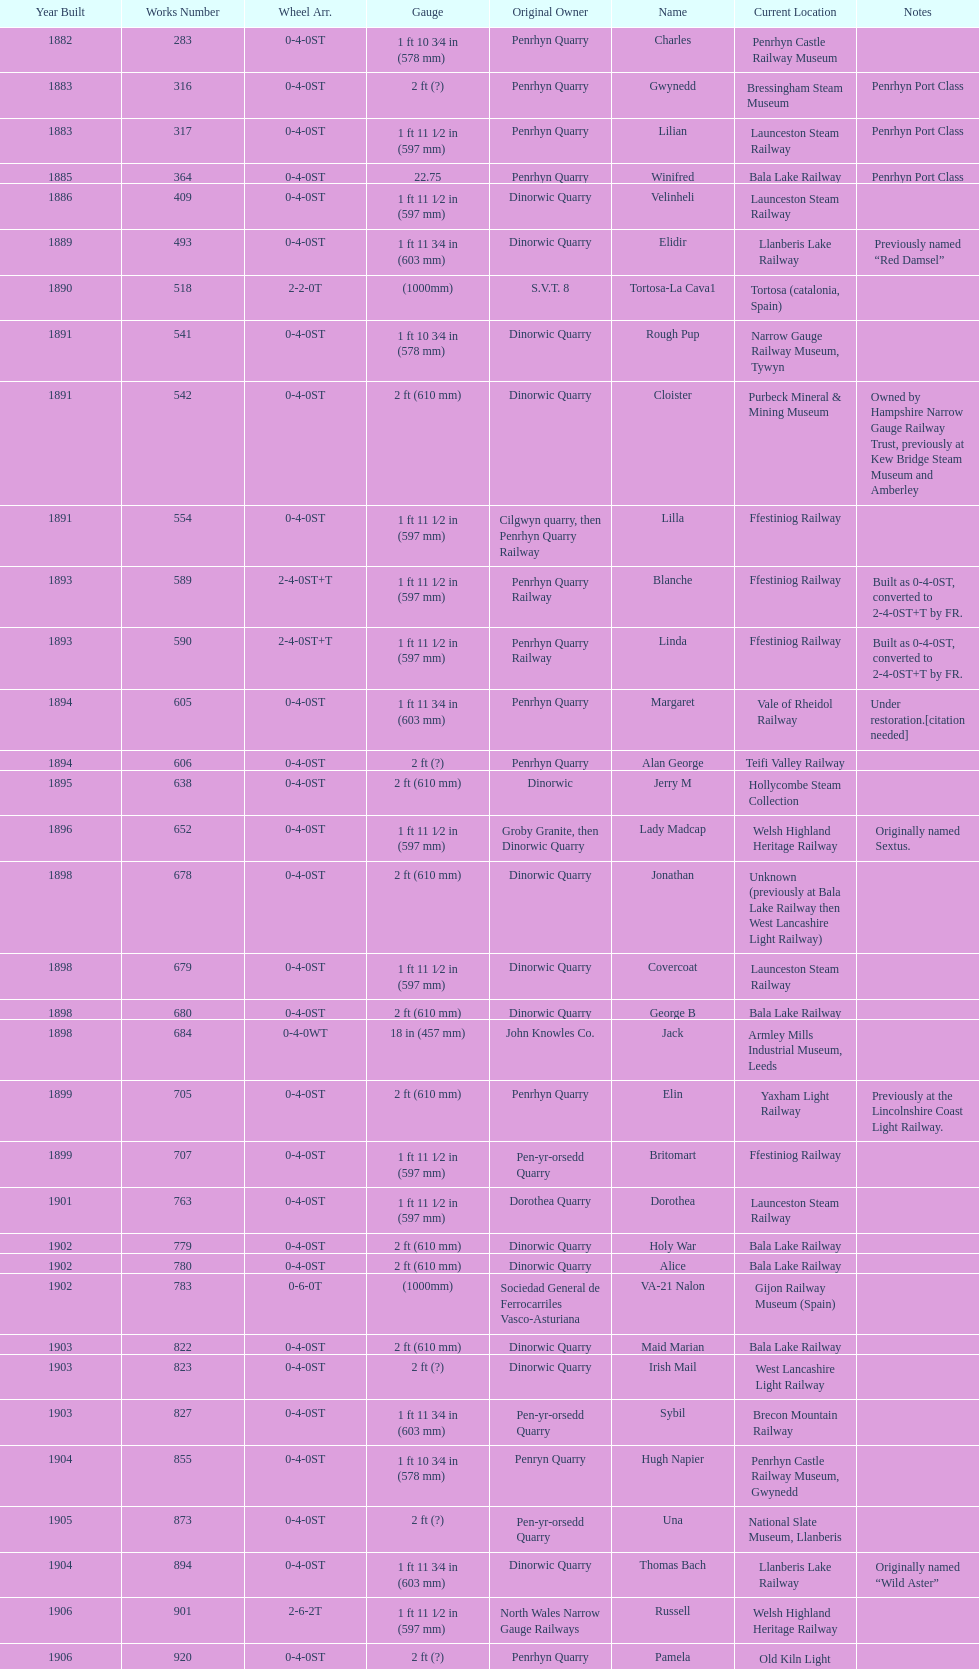Who possessed the most recently built locomotive? Trangkil Sugar Mill, Indonesia. Write the full table. {'header': ['Year Built', 'Works Number', 'Wheel Arr.', 'Gauge', 'Original Owner', 'Name', 'Current Location', 'Notes'], 'rows': [['1882', '283', '0-4-0ST', '1\xa0ft 10\xa03⁄4\xa0in (578\xa0mm)', 'Penrhyn Quarry', 'Charles', 'Penrhyn Castle Railway Museum', ''], ['1883', '316', '0-4-0ST', '2\xa0ft (?)', 'Penrhyn Quarry', 'Gwynedd', 'Bressingham Steam Museum', 'Penrhyn Port Class'], ['1883', '317', '0-4-0ST', '1\xa0ft 11\xa01⁄2\xa0in (597\xa0mm)', 'Penrhyn Quarry', 'Lilian', 'Launceston Steam Railway', 'Penrhyn Port Class'], ['1885', '364', '0-4-0ST', '22.75', 'Penrhyn Quarry', 'Winifred', 'Bala Lake Railway', 'Penrhyn Port Class'], ['1886', '409', '0-4-0ST', '1\xa0ft 11\xa01⁄2\xa0in (597\xa0mm)', 'Dinorwic Quarry', 'Velinheli', 'Launceston Steam Railway', ''], ['1889', '493', '0-4-0ST', '1\xa0ft 11\xa03⁄4\xa0in (603\xa0mm)', 'Dinorwic Quarry', 'Elidir', 'Llanberis Lake Railway', 'Previously named “Red Damsel”'], ['1890', '518', '2-2-0T', '(1000mm)', 'S.V.T. 8', 'Tortosa-La Cava1', 'Tortosa (catalonia, Spain)', ''], ['1891', '541', '0-4-0ST', '1\xa0ft 10\xa03⁄4\xa0in (578\xa0mm)', 'Dinorwic Quarry', 'Rough Pup', 'Narrow Gauge Railway Museum, Tywyn', ''], ['1891', '542', '0-4-0ST', '2\xa0ft (610\xa0mm)', 'Dinorwic Quarry', 'Cloister', 'Purbeck Mineral & Mining Museum', 'Owned by Hampshire Narrow Gauge Railway Trust, previously at Kew Bridge Steam Museum and Amberley'], ['1891', '554', '0-4-0ST', '1\xa0ft 11\xa01⁄2\xa0in (597\xa0mm)', 'Cilgwyn quarry, then Penrhyn Quarry Railway', 'Lilla', 'Ffestiniog Railway', ''], ['1893', '589', '2-4-0ST+T', '1\xa0ft 11\xa01⁄2\xa0in (597\xa0mm)', 'Penrhyn Quarry Railway', 'Blanche', 'Ffestiniog Railway', 'Built as 0-4-0ST, converted to 2-4-0ST+T by FR.'], ['1893', '590', '2-4-0ST+T', '1\xa0ft 11\xa01⁄2\xa0in (597\xa0mm)', 'Penrhyn Quarry Railway', 'Linda', 'Ffestiniog Railway', 'Built as 0-4-0ST, converted to 2-4-0ST+T by FR.'], ['1894', '605', '0-4-0ST', '1\xa0ft 11\xa03⁄4\xa0in (603\xa0mm)', 'Penrhyn Quarry', 'Margaret', 'Vale of Rheidol Railway', 'Under restoration.[citation needed]'], ['1894', '606', '0-4-0ST', '2\xa0ft (?)', 'Penrhyn Quarry', 'Alan George', 'Teifi Valley Railway', ''], ['1895', '638', '0-4-0ST', '2\xa0ft (610\xa0mm)', 'Dinorwic', 'Jerry M', 'Hollycombe Steam Collection', ''], ['1896', '652', '0-4-0ST', '1\xa0ft 11\xa01⁄2\xa0in (597\xa0mm)', 'Groby Granite, then Dinorwic Quarry', 'Lady Madcap', 'Welsh Highland Heritage Railway', 'Originally named Sextus.'], ['1898', '678', '0-4-0ST', '2\xa0ft (610\xa0mm)', 'Dinorwic Quarry', 'Jonathan', 'Unknown (previously at Bala Lake Railway then West Lancashire Light Railway)', ''], ['1898', '679', '0-4-0ST', '1\xa0ft 11\xa01⁄2\xa0in (597\xa0mm)', 'Dinorwic Quarry', 'Covercoat', 'Launceston Steam Railway', ''], ['1898', '680', '0-4-0ST', '2\xa0ft (610\xa0mm)', 'Dinorwic Quarry', 'George B', 'Bala Lake Railway', ''], ['1898', '684', '0-4-0WT', '18\xa0in (457\xa0mm)', 'John Knowles Co.', 'Jack', 'Armley Mills Industrial Museum, Leeds', ''], ['1899', '705', '0-4-0ST', '2\xa0ft (610\xa0mm)', 'Penrhyn Quarry', 'Elin', 'Yaxham Light Railway', 'Previously at the Lincolnshire Coast Light Railway.'], ['1899', '707', '0-4-0ST', '1\xa0ft 11\xa01⁄2\xa0in (597\xa0mm)', 'Pen-yr-orsedd Quarry', 'Britomart', 'Ffestiniog Railway', ''], ['1901', '763', '0-4-0ST', '1\xa0ft 11\xa01⁄2\xa0in (597\xa0mm)', 'Dorothea Quarry', 'Dorothea', 'Launceston Steam Railway', ''], ['1902', '779', '0-4-0ST', '2\xa0ft (610\xa0mm)', 'Dinorwic Quarry', 'Holy War', 'Bala Lake Railway', ''], ['1902', '780', '0-4-0ST', '2\xa0ft (610\xa0mm)', 'Dinorwic Quarry', 'Alice', 'Bala Lake Railway', ''], ['1902', '783', '0-6-0T', '(1000mm)', 'Sociedad General de Ferrocarriles Vasco-Asturiana', 'VA-21 Nalon', 'Gijon Railway Museum (Spain)', ''], ['1903', '822', '0-4-0ST', '2\xa0ft (610\xa0mm)', 'Dinorwic Quarry', 'Maid Marian', 'Bala Lake Railway', ''], ['1903', '823', '0-4-0ST', '2\xa0ft (?)', 'Dinorwic Quarry', 'Irish Mail', 'West Lancashire Light Railway', ''], ['1903', '827', '0-4-0ST', '1\xa0ft 11\xa03⁄4\xa0in (603\xa0mm)', 'Pen-yr-orsedd Quarry', 'Sybil', 'Brecon Mountain Railway', ''], ['1904', '855', '0-4-0ST', '1\xa0ft 10\xa03⁄4\xa0in (578\xa0mm)', 'Penryn Quarry', 'Hugh Napier', 'Penrhyn Castle Railway Museum, Gwynedd', ''], ['1905', '873', '0-4-0ST', '2\xa0ft (?)', 'Pen-yr-orsedd Quarry', 'Una', 'National Slate Museum, Llanberis', ''], ['1904', '894', '0-4-0ST', '1\xa0ft 11\xa03⁄4\xa0in (603\xa0mm)', 'Dinorwic Quarry', 'Thomas Bach', 'Llanberis Lake Railway', 'Originally named “Wild Aster”'], ['1906', '901', '2-6-2T', '1\xa0ft 11\xa01⁄2\xa0in (597\xa0mm)', 'North Wales Narrow Gauge Railways', 'Russell', 'Welsh Highland Heritage Railway', ''], ['1906', '920', '0-4-0ST', '2\xa0ft (?)', 'Penrhyn Quarry', 'Pamela', 'Old Kiln Light Railway', ''], ['1909', '994', '0-4-0ST', '2\xa0ft (?)', 'Penrhyn Quarry', 'Bill Harvey', 'Bressingham Steam Museum', 'previously George Sholto'], ['1918', '1312', '4-6-0T', '1\xa0ft\xa011\xa01⁄2\xa0in (597\xa0mm)', 'British War Department\\nEFOP #203', '---', 'Pampas Safari, Gravataí, RS, Brazil', '[citation needed]'], ['1918\\nor\\n1921?', '1313', '0-6-2T', '3\xa0ft\xa03\xa03⁄8\xa0in (1,000\xa0mm)', 'British War Department\\nUsina Leão Utinga #1\\nUsina Laginha #1', '---', 'Usina Laginha, União dos Palmares, AL, Brazil', '[citation needed]'], ['1920', '1404', '0-4-0WT', '18\xa0in (457\xa0mm)', 'John Knowles Co.', 'Gwen', 'Richard Farmer current owner, Northridge, California, USA', ''], ['1922', '1429', '0-4-0ST', '2\xa0ft (610\xa0mm)', 'Dinorwic', 'Lady Joan', 'Bredgar and Wormshill Light Railway', ''], ['1922', '1430', '0-4-0ST', '1\xa0ft 11\xa03⁄4\xa0in (603\xa0mm)', 'Dinorwic Quarry', 'Dolbadarn', 'Llanberis Lake Railway', ''], ['1937', '1859', '0-4-2T', '2\xa0ft (?)', 'Umtwalumi Valley Estate, Natal', '16 Carlisle', 'South Tynedale Railway', ''], ['1940', '2075', '0-4-2T', '2\xa0ft (?)', 'Chaka’s Kraal Sugar Estates, Natal', 'Chaka’s Kraal No. 6', 'North Gloucestershire Railway', ''], ['1954', '3815', '2-6-2T', '2\xa0ft 6\xa0in (762\xa0mm)', 'Sierra Leone Government Railway', '14', 'Welshpool and Llanfair Light Railway', ''], ['1971', '3902', '0-4-2ST', '2\xa0ft (610\xa0mm)', 'Trangkil Sugar Mill, Indonesia', 'Trangkil No.4', 'Statfold Barn Railway', 'Converted from 750\xa0mm (2\xa0ft\xa05\xa01⁄2\xa0in) gauge. Last steam locomotive to be built by Hunslet, and the last industrial steam locomotive built in Britain.']]} 